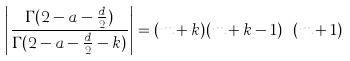<formula> <loc_0><loc_0><loc_500><loc_500>\left | \frac { \Gamma ( 2 - a - \frac { d } { 2 } ) } { \Gamma ( 2 - a - \frac { d } { 2 } - k ) } \right | = ( m + k ) ( m + k - 1 ) \cdots ( m + 1 )</formula> 